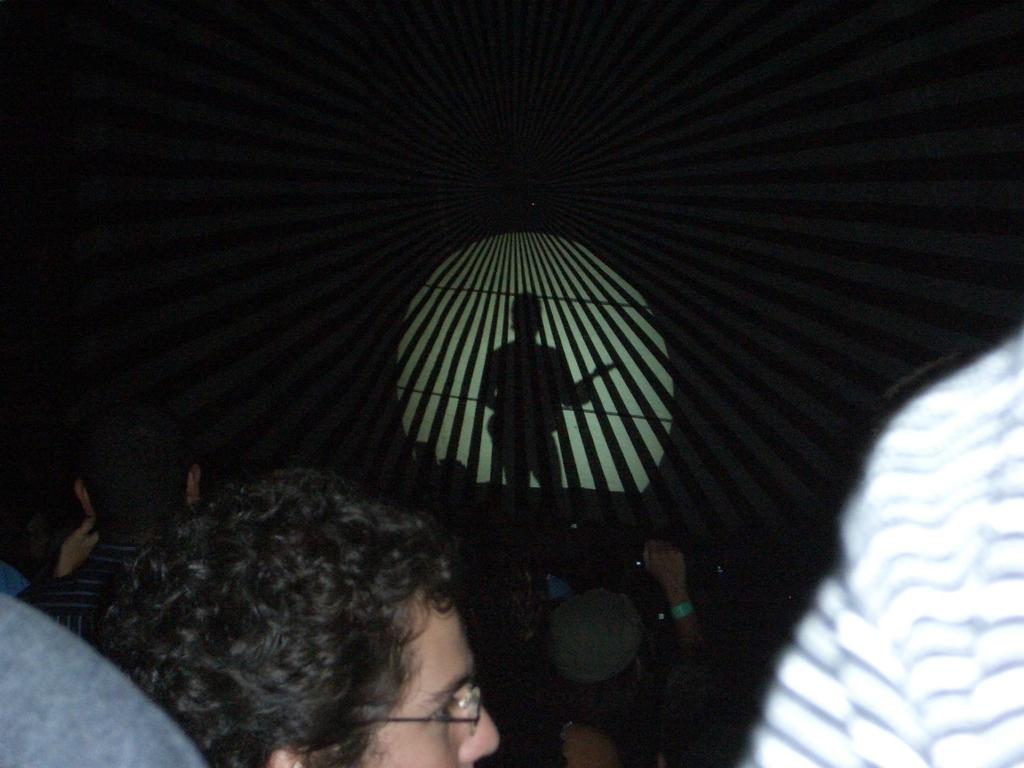How many people are in the image? There are persons in the image. Can you describe the shadow in the image? There is a shadow of a person in front of the other persons. What type of government is depicted in the image? There is no reference to a government in the image, as it features persons and a shadow. 